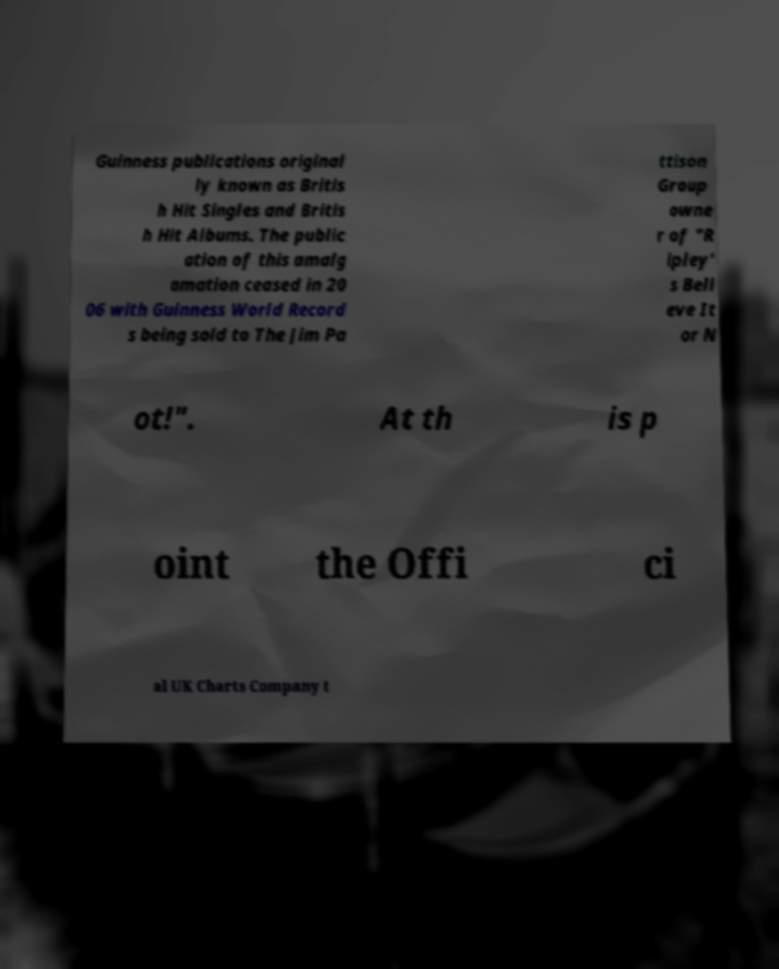Could you assist in decoding the text presented in this image and type it out clearly? Guinness publications original ly known as Britis h Hit Singles and Britis h Hit Albums. The public ation of this amalg amation ceased in 20 06 with Guinness World Record s being sold to The Jim Pa ttison Group owne r of "R ipley' s Beli eve It or N ot!". At th is p oint the Offi ci al UK Charts Company t 